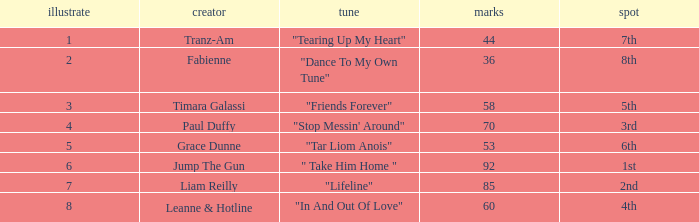What's the typical pull for the song "stop messin' around"? 4.0. 